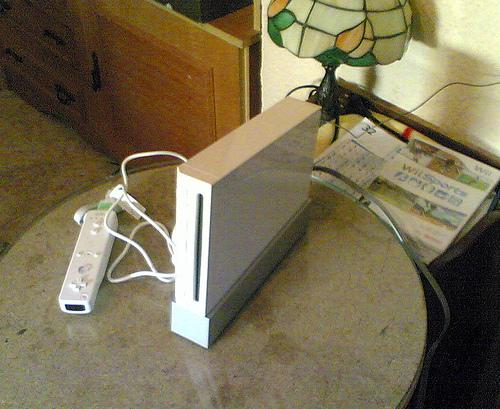Question: what color is the WII?
Choices:
A. Red.
B. Yellow.
C. Cream.
D. White.
Answer with the letter. Answer: D Question: what color is the WII power cord?
Choices:
A. Black.
B. Gray.
C. Silver.
D. Brown.
Answer with the letter. Answer: B 